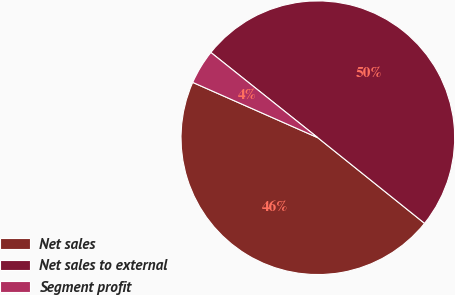<chart> <loc_0><loc_0><loc_500><loc_500><pie_chart><fcel>Net sales<fcel>Net sales to external<fcel>Segment profit<nl><fcel>45.87%<fcel>50.05%<fcel>4.08%<nl></chart> 